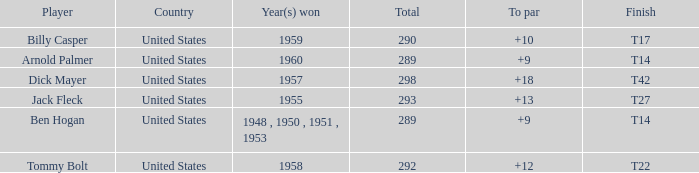What is Player, when Year(s) Won is 1955? Jack Fleck. 